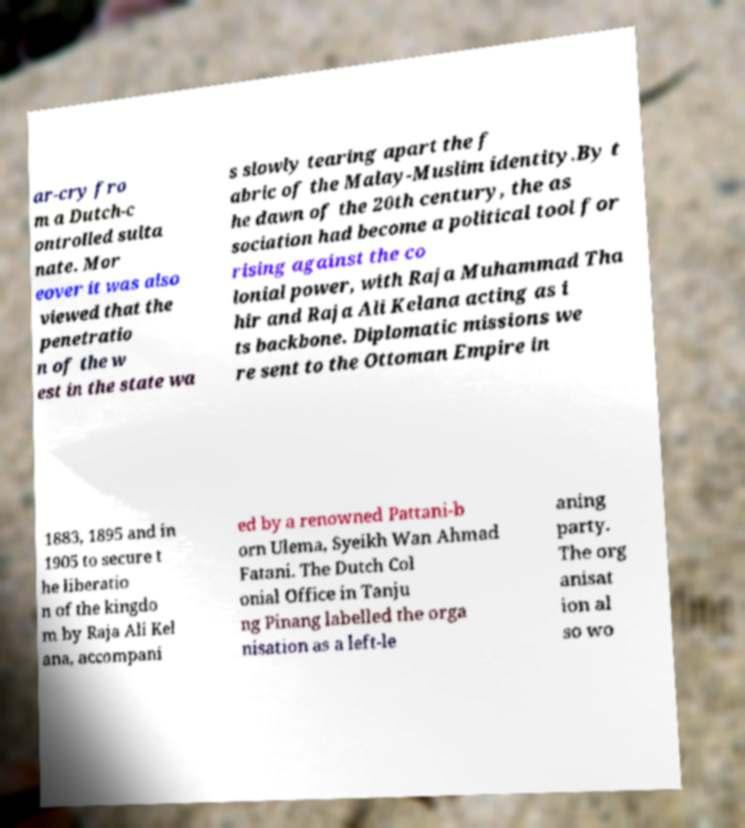What messages or text are displayed in this image? I need them in a readable, typed format. ar-cry fro m a Dutch-c ontrolled sulta nate. Mor eover it was also viewed that the penetratio n of the w est in the state wa s slowly tearing apart the f abric of the Malay-Muslim identity.By t he dawn of the 20th century, the as sociation had become a political tool for rising against the co lonial power, with Raja Muhammad Tha hir and Raja Ali Kelana acting as i ts backbone. Diplomatic missions we re sent to the Ottoman Empire in 1883, 1895 and in 1905 to secure t he liberatio n of the kingdo m by Raja Ali Kel ana, accompani ed by a renowned Pattani-b orn Ulema, Syeikh Wan Ahmad Fatani. The Dutch Col onial Office in Tanju ng Pinang labelled the orga nisation as a left-le aning party. The org anisat ion al so wo 